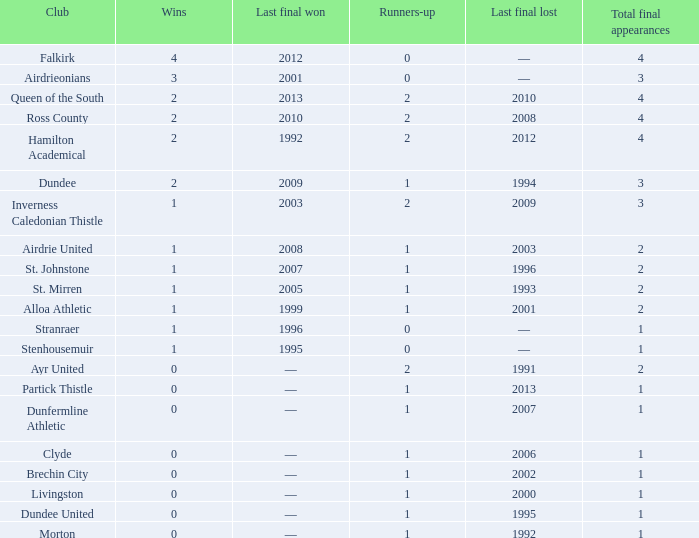What is the number of wins for dunfermline athletic when they have fewer than 2 total final appearances? 0.0. 